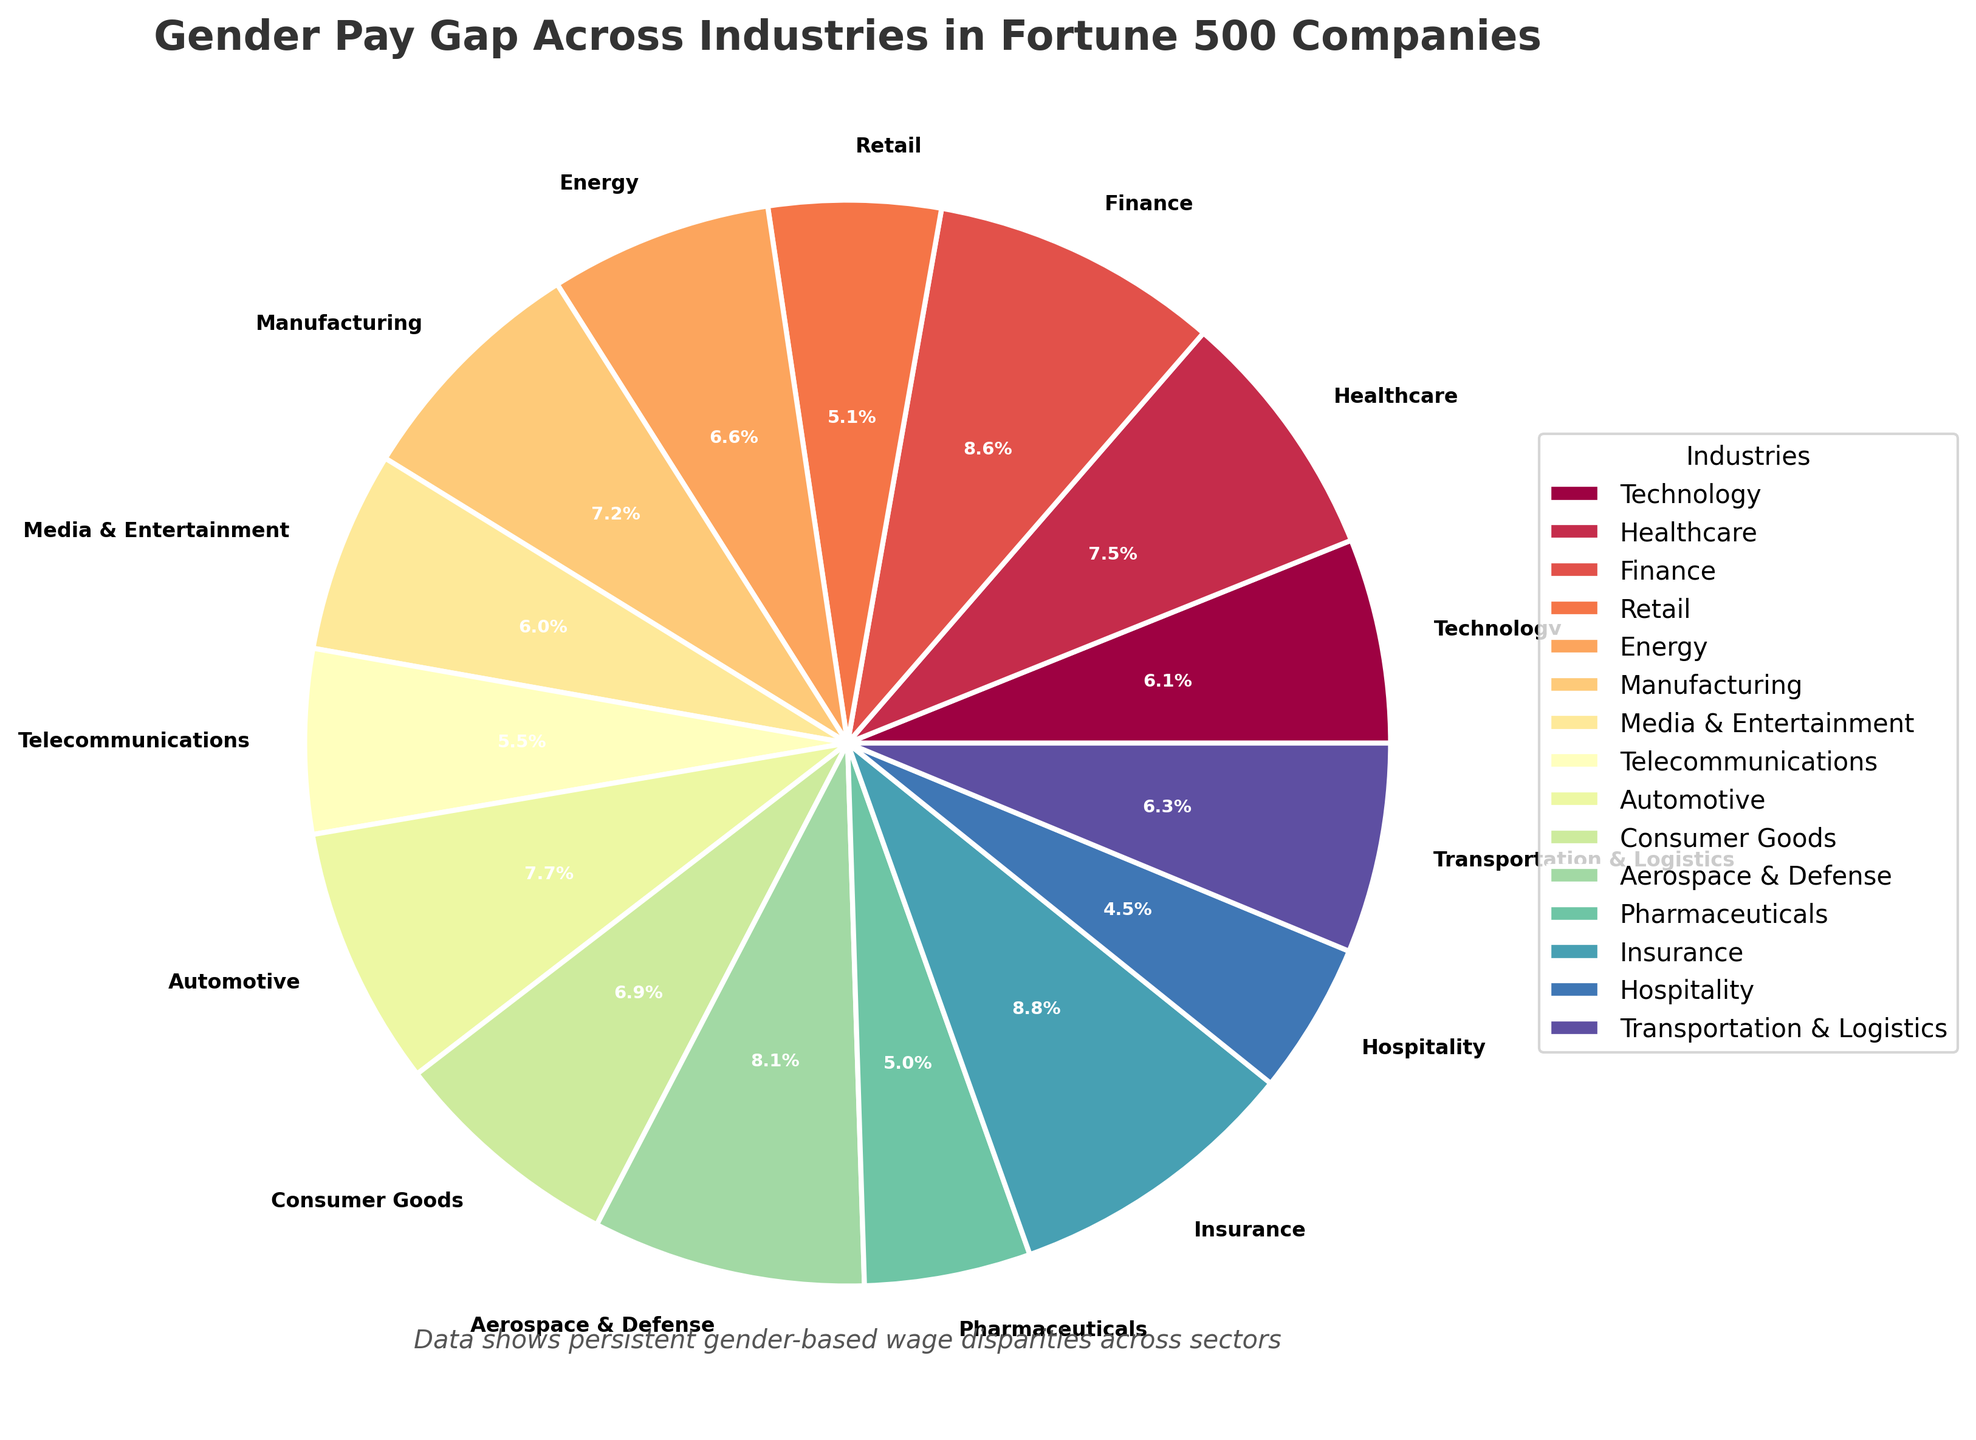Which industry has the smallest gender pay gap percentage? Scan the pie chart for the lowest percentage value. The smallest gender pay gap is in Hospitality with 13.5%.
Answer: Hospitality Which industry has the largest gender pay gap percentage? Look for the highest percentage value in the pie chart. The largest gender pay gap is in Insurance with 26.2%.
Answer: Insurance How much larger is the gender pay gap in Finance compared to Retail? Locate the percentages for Finance (25.7%) and Retail (15.3%) and find the difference. Subtract 15.3 from 25.7 to get 10.4.
Answer: 10.4 What is the average gender pay gap across all the industries? Sum all the percentages and divide by the number of industries. (18.2 + 22.5 + 25.7 + 15.3 + 19.8 + 21.6 + 17.9 + 16.4 + 23.1 + 20.7 + 24.3 + 14.8 + 26.2 + 13.5 + 18.7) / 15 = 19.98.
Answer: 19.98 Identify the industries with a gender pay gap less than 20%. Look for pie slices with percentages less than 20%. These industries are Technology (18.2%), Retail (15.3%), Media & Entertainment (17.9%), Telecommunications (16.4%), Pharmaceuticals (14.8%), Hospitality (13.5%), and Transportation & Logistics (18.7%).
Answer: Technology, Retail, Media & Entertainment, Telecommunications, Pharmaceuticals, Hospitality, Transportation & Logistics Which sectors have a higher gender pay gap than Healthcare? Find sectors with percentages greater than Healthcare's 22.5%. These sectors are Finance (25.7%), Automotive (23.1%), Aerospace & Defense (24.3%), and Insurance (26.2%).
Answer: Finance, Automotive, Aerospace & Defense, Insurance What is the difference between the gender pay gaps in Energy and Pharmaceuticals? Energy has a gap of 19.8%, and Pharmaceuticals have 14.8%. Subtract 14.8 from 19.8 to get 5.0.
Answer: 5.0 Is the gender pay gap in Manufacturing higher or lower than in Consumer Goods? Compare the values for Manufacturing (21.6%) and Consumer Goods (20.7%). Manufacturing's gender pay gap is higher.
Answer: Higher Which industry close to the highest gender pay gap has a significant wage disparity of more than 24%? Identify the percentages greater than 24%. The industries are Finance (25.7%), Aerospace & Defense (24.3%), and Insurance (26.2%). The highest is Insurance.
Answer: Insurance What is the total percentage value of the gender pay gaps for Media & Entertainment, Telecommunications, and Automotive? Add the percentages for the three industries: 17.9 + 16.4 + 23.1 = 57.4.
Answer: 57.4 